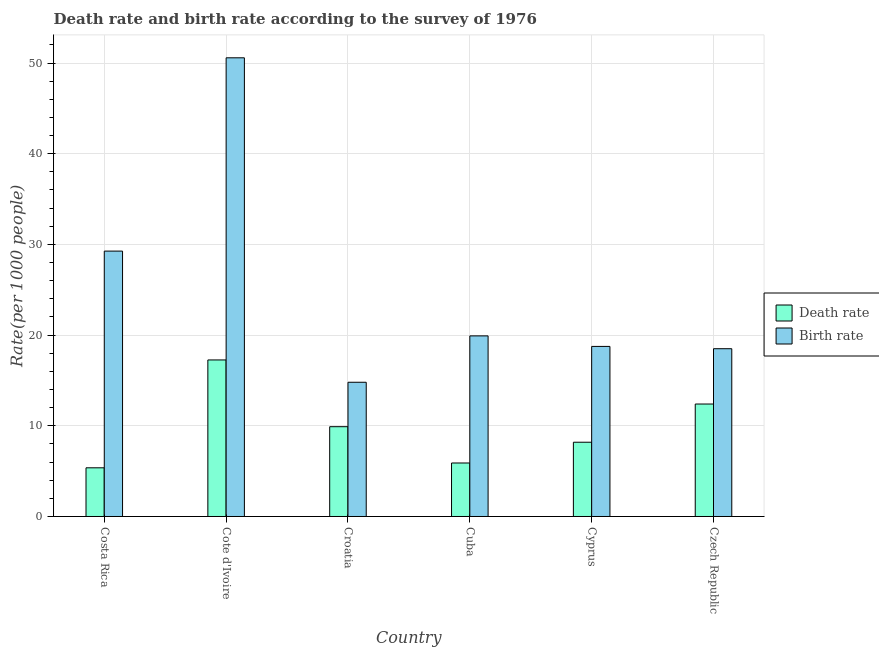How many different coloured bars are there?
Offer a very short reply. 2. How many groups of bars are there?
Your response must be concise. 6. Are the number of bars on each tick of the X-axis equal?
Provide a short and direct response. Yes. How many bars are there on the 6th tick from the left?
Provide a short and direct response. 2. What is the label of the 1st group of bars from the left?
Make the answer very short. Costa Rica. In how many cases, is the number of bars for a given country not equal to the number of legend labels?
Your response must be concise. 0. Across all countries, what is the maximum death rate?
Give a very brief answer. 17.26. Across all countries, what is the minimum death rate?
Ensure brevity in your answer.  5.37. In which country was the birth rate maximum?
Your answer should be compact. Cote d'Ivoire. In which country was the birth rate minimum?
Offer a very short reply. Croatia. What is the total birth rate in the graph?
Make the answer very short. 151.81. What is the difference between the birth rate in Costa Rica and that in Croatia?
Offer a very short reply. 14.46. What is the difference between the death rate in Cuba and the birth rate in Costa Rica?
Make the answer very short. -23.37. What is the average birth rate per country?
Give a very brief answer. 25.3. What is the difference between the birth rate and death rate in Cyprus?
Your answer should be very brief. 10.56. What is the ratio of the death rate in Cuba to that in Cyprus?
Offer a terse response. 0.72. Is the death rate in Croatia less than that in Czech Republic?
Make the answer very short. Yes. Is the difference between the birth rate in Costa Rica and Croatia greater than the difference between the death rate in Costa Rica and Croatia?
Your answer should be compact. Yes. What is the difference between the highest and the second highest birth rate?
Provide a succinct answer. 21.31. What is the difference between the highest and the lowest death rate?
Provide a short and direct response. 11.89. Is the sum of the death rate in Croatia and Cyprus greater than the maximum birth rate across all countries?
Offer a very short reply. No. What does the 1st bar from the left in Costa Rica represents?
Ensure brevity in your answer.  Death rate. What does the 2nd bar from the right in Cyprus represents?
Offer a terse response. Death rate. Are all the bars in the graph horizontal?
Your answer should be compact. No. Does the graph contain any zero values?
Offer a terse response. No. Does the graph contain grids?
Your response must be concise. Yes. How many legend labels are there?
Provide a short and direct response. 2. What is the title of the graph?
Your answer should be very brief. Death rate and birth rate according to the survey of 1976. Does "Fixed telephone" appear as one of the legend labels in the graph?
Your answer should be compact. No. What is the label or title of the X-axis?
Your answer should be very brief. Country. What is the label or title of the Y-axis?
Give a very brief answer. Rate(per 1000 people). What is the Rate(per 1000 people) of Death rate in Costa Rica?
Make the answer very short. 5.37. What is the Rate(per 1000 people) in Birth rate in Costa Rica?
Make the answer very short. 29.26. What is the Rate(per 1000 people) in Death rate in Cote d'Ivoire?
Give a very brief answer. 17.26. What is the Rate(per 1000 people) of Birth rate in Cote d'Ivoire?
Ensure brevity in your answer.  50.58. What is the Rate(per 1000 people) of Death rate in Cuba?
Your response must be concise. 5.9. What is the Rate(per 1000 people) in Birth rate in Cuba?
Ensure brevity in your answer.  19.91. What is the Rate(per 1000 people) in Death rate in Cyprus?
Your answer should be compact. 8.19. What is the Rate(per 1000 people) of Birth rate in Cyprus?
Ensure brevity in your answer.  18.75. Across all countries, what is the maximum Rate(per 1000 people) of Death rate?
Keep it short and to the point. 17.26. Across all countries, what is the maximum Rate(per 1000 people) of Birth rate?
Your response must be concise. 50.58. Across all countries, what is the minimum Rate(per 1000 people) in Death rate?
Offer a very short reply. 5.37. What is the total Rate(per 1000 people) in Death rate in the graph?
Your answer should be very brief. 59.02. What is the total Rate(per 1000 people) of Birth rate in the graph?
Offer a terse response. 151.81. What is the difference between the Rate(per 1000 people) in Death rate in Costa Rica and that in Cote d'Ivoire?
Make the answer very short. -11.89. What is the difference between the Rate(per 1000 people) of Birth rate in Costa Rica and that in Cote d'Ivoire?
Provide a succinct answer. -21.31. What is the difference between the Rate(per 1000 people) of Death rate in Costa Rica and that in Croatia?
Keep it short and to the point. -4.53. What is the difference between the Rate(per 1000 people) in Birth rate in Costa Rica and that in Croatia?
Ensure brevity in your answer.  14.46. What is the difference between the Rate(per 1000 people) of Death rate in Costa Rica and that in Cuba?
Make the answer very short. -0.53. What is the difference between the Rate(per 1000 people) of Birth rate in Costa Rica and that in Cuba?
Provide a short and direct response. 9.35. What is the difference between the Rate(per 1000 people) in Death rate in Costa Rica and that in Cyprus?
Your answer should be compact. -2.82. What is the difference between the Rate(per 1000 people) in Birth rate in Costa Rica and that in Cyprus?
Provide a succinct answer. 10.51. What is the difference between the Rate(per 1000 people) of Death rate in Costa Rica and that in Czech Republic?
Your answer should be very brief. -7.03. What is the difference between the Rate(per 1000 people) in Birth rate in Costa Rica and that in Czech Republic?
Give a very brief answer. 10.76. What is the difference between the Rate(per 1000 people) in Death rate in Cote d'Ivoire and that in Croatia?
Your answer should be compact. 7.36. What is the difference between the Rate(per 1000 people) in Birth rate in Cote d'Ivoire and that in Croatia?
Ensure brevity in your answer.  35.78. What is the difference between the Rate(per 1000 people) in Death rate in Cote d'Ivoire and that in Cuba?
Your response must be concise. 11.36. What is the difference between the Rate(per 1000 people) in Birth rate in Cote d'Ivoire and that in Cuba?
Provide a short and direct response. 30.66. What is the difference between the Rate(per 1000 people) in Death rate in Cote d'Ivoire and that in Cyprus?
Your response must be concise. 9.07. What is the difference between the Rate(per 1000 people) in Birth rate in Cote d'Ivoire and that in Cyprus?
Your answer should be compact. 31.82. What is the difference between the Rate(per 1000 people) in Death rate in Cote d'Ivoire and that in Czech Republic?
Give a very brief answer. 4.86. What is the difference between the Rate(per 1000 people) in Birth rate in Cote d'Ivoire and that in Czech Republic?
Your answer should be very brief. 32.08. What is the difference between the Rate(per 1000 people) in Death rate in Croatia and that in Cuba?
Offer a very short reply. 4. What is the difference between the Rate(per 1000 people) in Birth rate in Croatia and that in Cuba?
Offer a very short reply. -5.12. What is the difference between the Rate(per 1000 people) of Death rate in Croatia and that in Cyprus?
Provide a succinct answer. 1.71. What is the difference between the Rate(per 1000 people) of Birth rate in Croatia and that in Cyprus?
Provide a succinct answer. -3.95. What is the difference between the Rate(per 1000 people) in Birth rate in Croatia and that in Czech Republic?
Your answer should be compact. -3.7. What is the difference between the Rate(per 1000 people) in Death rate in Cuba and that in Cyprus?
Your answer should be compact. -2.29. What is the difference between the Rate(per 1000 people) in Birth rate in Cuba and that in Cyprus?
Make the answer very short. 1.16. What is the difference between the Rate(per 1000 people) in Death rate in Cuba and that in Czech Republic?
Ensure brevity in your answer.  -6.5. What is the difference between the Rate(per 1000 people) in Birth rate in Cuba and that in Czech Republic?
Offer a very short reply. 1.42. What is the difference between the Rate(per 1000 people) in Death rate in Cyprus and that in Czech Republic?
Offer a terse response. -4.21. What is the difference between the Rate(per 1000 people) in Birth rate in Cyprus and that in Czech Republic?
Make the answer very short. 0.25. What is the difference between the Rate(per 1000 people) of Death rate in Costa Rica and the Rate(per 1000 people) of Birth rate in Cote d'Ivoire?
Make the answer very short. -45.21. What is the difference between the Rate(per 1000 people) in Death rate in Costa Rica and the Rate(per 1000 people) in Birth rate in Croatia?
Your answer should be compact. -9.43. What is the difference between the Rate(per 1000 people) of Death rate in Costa Rica and the Rate(per 1000 people) of Birth rate in Cuba?
Give a very brief answer. -14.55. What is the difference between the Rate(per 1000 people) of Death rate in Costa Rica and the Rate(per 1000 people) of Birth rate in Cyprus?
Provide a short and direct response. -13.39. What is the difference between the Rate(per 1000 people) in Death rate in Costa Rica and the Rate(per 1000 people) in Birth rate in Czech Republic?
Make the answer very short. -13.13. What is the difference between the Rate(per 1000 people) of Death rate in Cote d'Ivoire and the Rate(per 1000 people) of Birth rate in Croatia?
Provide a succinct answer. 2.46. What is the difference between the Rate(per 1000 people) of Death rate in Cote d'Ivoire and the Rate(per 1000 people) of Birth rate in Cuba?
Give a very brief answer. -2.65. What is the difference between the Rate(per 1000 people) in Death rate in Cote d'Ivoire and the Rate(per 1000 people) in Birth rate in Cyprus?
Provide a succinct answer. -1.49. What is the difference between the Rate(per 1000 people) in Death rate in Cote d'Ivoire and the Rate(per 1000 people) in Birth rate in Czech Republic?
Your answer should be compact. -1.24. What is the difference between the Rate(per 1000 people) of Death rate in Croatia and the Rate(per 1000 people) of Birth rate in Cuba?
Your answer should be very brief. -10.02. What is the difference between the Rate(per 1000 people) of Death rate in Croatia and the Rate(per 1000 people) of Birth rate in Cyprus?
Your response must be concise. -8.85. What is the difference between the Rate(per 1000 people) in Death rate in Cuba and the Rate(per 1000 people) in Birth rate in Cyprus?
Provide a short and direct response. -12.86. What is the difference between the Rate(per 1000 people) of Death rate in Cuba and the Rate(per 1000 people) of Birth rate in Czech Republic?
Give a very brief answer. -12.6. What is the difference between the Rate(per 1000 people) of Death rate in Cyprus and the Rate(per 1000 people) of Birth rate in Czech Republic?
Your answer should be compact. -10.31. What is the average Rate(per 1000 people) in Death rate per country?
Ensure brevity in your answer.  9.84. What is the average Rate(per 1000 people) in Birth rate per country?
Your response must be concise. 25.3. What is the difference between the Rate(per 1000 people) in Death rate and Rate(per 1000 people) in Birth rate in Costa Rica?
Your response must be concise. -23.9. What is the difference between the Rate(per 1000 people) in Death rate and Rate(per 1000 people) in Birth rate in Cote d'Ivoire?
Offer a terse response. -33.31. What is the difference between the Rate(per 1000 people) in Death rate and Rate(per 1000 people) in Birth rate in Cuba?
Your answer should be compact. -14.02. What is the difference between the Rate(per 1000 people) in Death rate and Rate(per 1000 people) in Birth rate in Cyprus?
Provide a short and direct response. -10.56. What is the ratio of the Rate(per 1000 people) in Death rate in Costa Rica to that in Cote d'Ivoire?
Your answer should be very brief. 0.31. What is the ratio of the Rate(per 1000 people) in Birth rate in Costa Rica to that in Cote d'Ivoire?
Your answer should be compact. 0.58. What is the ratio of the Rate(per 1000 people) in Death rate in Costa Rica to that in Croatia?
Ensure brevity in your answer.  0.54. What is the ratio of the Rate(per 1000 people) of Birth rate in Costa Rica to that in Croatia?
Your answer should be compact. 1.98. What is the ratio of the Rate(per 1000 people) in Death rate in Costa Rica to that in Cuba?
Your answer should be very brief. 0.91. What is the ratio of the Rate(per 1000 people) in Birth rate in Costa Rica to that in Cuba?
Offer a very short reply. 1.47. What is the ratio of the Rate(per 1000 people) in Death rate in Costa Rica to that in Cyprus?
Your answer should be very brief. 0.66. What is the ratio of the Rate(per 1000 people) in Birth rate in Costa Rica to that in Cyprus?
Offer a very short reply. 1.56. What is the ratio of the Rate(per 1000 people) of Death rate in Costa Rica to that in Czech Republic?
Your answer should be compact. 0.43. What is the ratio of the Rate(per 1000 people) of Birth rate in Costa Rica to that in Czech Republic?
Offer a very short reply. 1.58. What is the ratio of the Rate(per 1000 people) in Death rate in Cote d'Ivoire to that in Croatia?
Your response must be concise. 1.74. What is the ratio of the Rate(per 1000 people) in Birth rate in Cote d'Ivoire to that in Croatia?
Offer a very short reply. 3.42. What is the ratio of the Rate(per 1000 people) in Death rate in Cote d'Ivoire to that in Cuba?
Offer a very short reply. 2.93. What is the ratio of the Rate(per 1000 people) in Birth rate in Cote d'Ivoire to that in Cuba?
Make the answer very short. 2.54. What is the ratio of the Rate(per 1000 people) in Death rate in Cote d'Ivoire to that in Cyprus?
Make the answer very short. 2.11. What is the ratio of the Rate(per 1000 people) in Birth rate in Cote d'Ivoire to that in Cyprus?
Make the answer very short. 2.7. What is the ratio of the Rate(per 1000 people) in Death rate in Cote d'Ivoire to that in Czech Republic?
Your answer should be compact. 1.39. What is the ratio of the Rate(per 1000 people) in Birth rate in Cote d'Ivoire to that in Czech Republic?
Offer a terse response. 2.73. What is the ratio of the Rate(per 1000 people) of Death rate in Croatia to that in Cuba?
Your answer should be compact. 1.68. What is the ratio of the Rate(per 1000 people) of Birth rate in Croatia to that in Cuba?
Your answer should be compact. 0.74. What is the ratio of the Rate(per 1000 people) in Death rate in Croatia to that in Cyprus?
Ensure brevity in your answer.  1.21. What is the ratio of the Rate(per 1000 people) in Birth rate in Croatia to that in Cyprus?
Provide a short and direct response. 0.79. What is the ratio of the Rate(per 1000 people) of Death rate in Croatia to that in Czech Republic?
Offer a very short reply. 0.8. What is the ratio of the Rate(per 1000 people) in Birth rate in Croatia to that in Czech Republic?
Offer a very short reply. 0.8. What is the ratio of the Rate(per 1000 people) of Death rate in Cuba to that in Cyprus?
Offer a terse response. 0.72. What is the ratio of the Rate(per 1000 people) in Birth rate in Cuba to that in Cyprus?
Ensure brevity in your answer.  1.06. What is the ratio of the Rate(per 1000 people) in Death rate in Cuba to that in Czech Republic?
Make the answer very short. 0.48. What is the ratio of the Rate(per 1000 people) of Birth rate in Cuba to that in Czech Republic?
Provide a succinct answer. 1.08. What is the ratio of the Rate(per 1000 people) of Death rate in Cyprus to that in Czech Republic?
Make the answer very short. 0.66. What is the ratio of the Rate(per 1000 people) in Birth rate in Cyprus to that in Czech Republic?
Provide a short and direct response. 1.01. What is the difference between the highest and the second highest Rate(per 1000 people) in Death rate?
Offer a terse response. 4.86. What is the difference between the highest and the second highest Rate(per 1000 people) of Birth rate?
Your answer should be very brief. 21.31. What is the difference between the highest and the lowest Rate(per 1000 people) in Death rate?
Keep it short and to the point. 11.89. What is the difference between the highest and the lowest Rate(per 1000 people) of Birth rate?
Your answer should be compact. 35.78. 